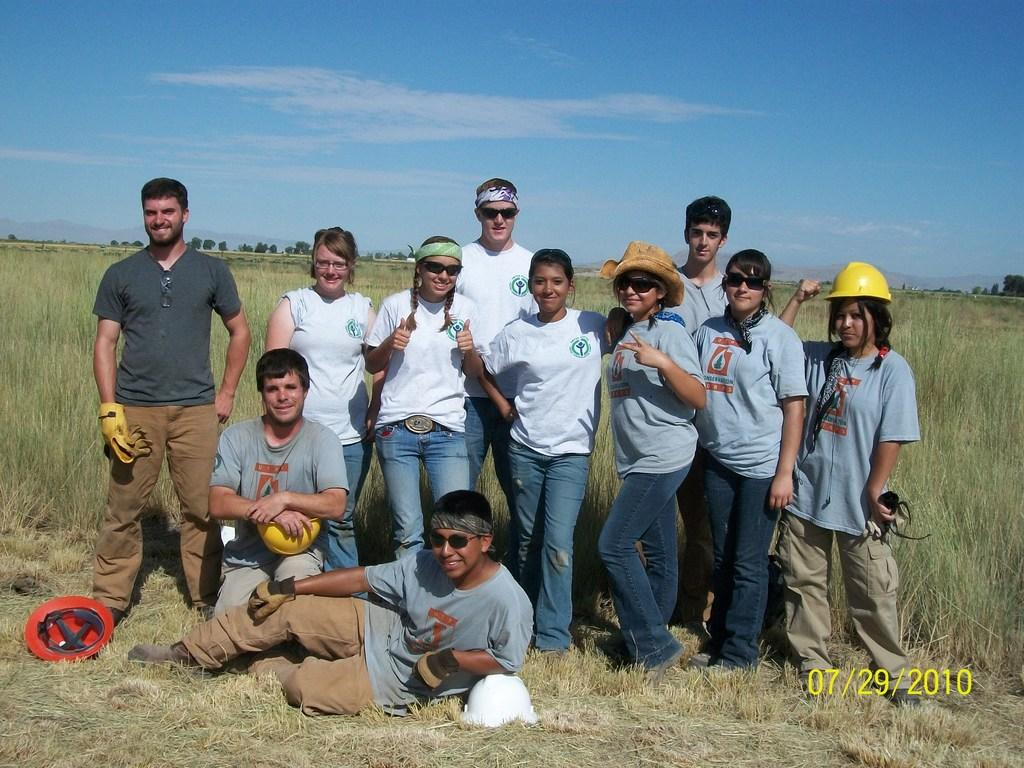How many people are in the image? There is a group of people in the image. What is the surface on which the people are standing or sitting? The people are on the grass. What type of natural vegetation is visible in the image? There are trees surrounding the people. What is the color of the sky in the image? The sky is blue in the image. What type of paint is being used by the people in the image? There is no indication in the image that the people are using paint, so it cannot be determined from the picture. 